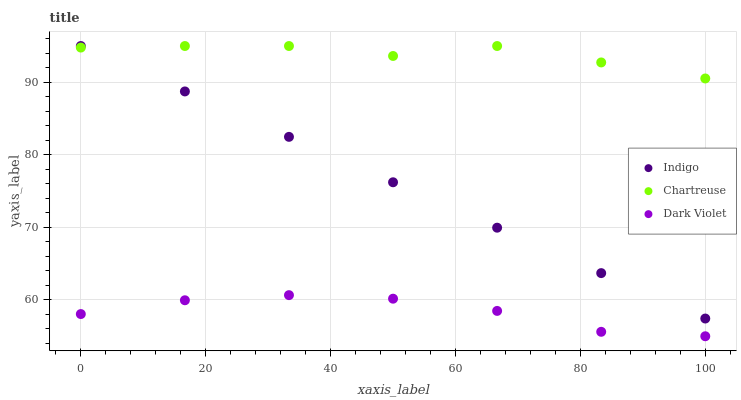Does Dark Violet have the minimum area under the curve?
Answer yes or no. Yes. Does Chartreuse have the maximum area under the curve?
Answer yes or no. Yes. Does Indigo have the minimum area under the curve?
Answer yes or no. No. Does Indigo have the maximum area under the curve?
Answer yes or no. No. Is Indigo the smoothest?
Answer yes or no. Yes. Is Chartreuse the roughest?
Answer yes or no. Yes. Is Dark Violet the smoothest?
Answer yes or no. No. Is Dark Violet the roughest?
Answer yes or no. No. Does Dark Violet have the lowest value?
Answer yes or no. Yes. Does Indigo have the lowest value?
Answer yes or no. No. Does Indigo have the highest value?
Answer yes or no. Yes. Does Dark Violet have the highest value?
Answer yes or no. No. Is Dark Violet less than Chartreuse?
Answer yes or no. Yes. Is Chartreuse greater than Dark Violet?
Answer yes or no. Yes. Does Indigo intersect Chartreuse?
Answer yes or no. Yes. Is Indigo less than Chartreuse?
Answer yes or no. No. Is Indigo greater than Chartreuse?
Answer yes or no. No. Does Dark Violet intersect Chartreuse?
Answer yes or no. No. 